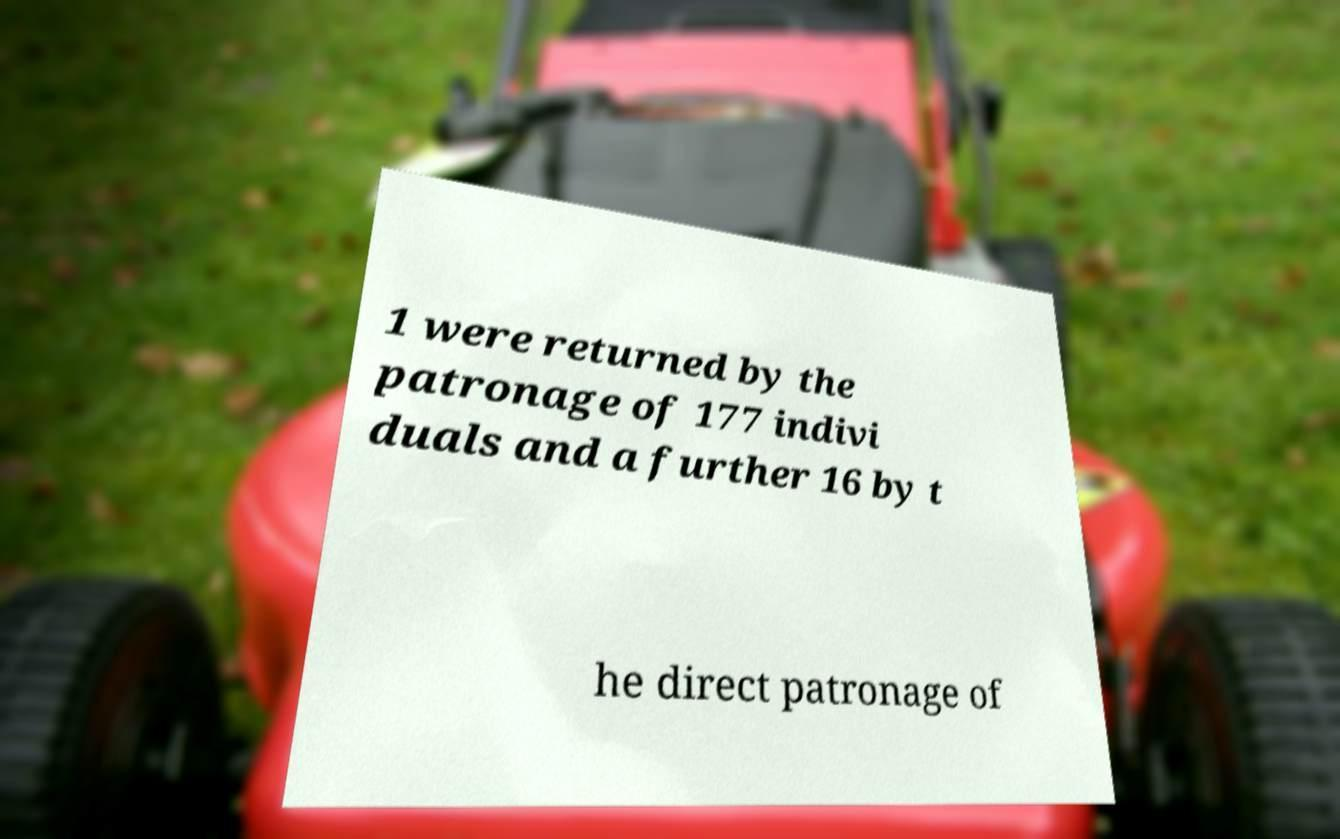Could you assist in decoding the text presented in this image and type it out clearly? 1 were returned by the patronage of 177 indivi duals and a further 16 by t he direct patronage of 